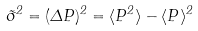<formula> <loc_0><loc_0><loc_500><loc_500>\tilde { \sigma } ^ { 2 } = ( \Delta P ) ^ { 2 } = \langle P ^ { 2 } \rangle - \langle P \rangle ^ { 2 }</formula> 